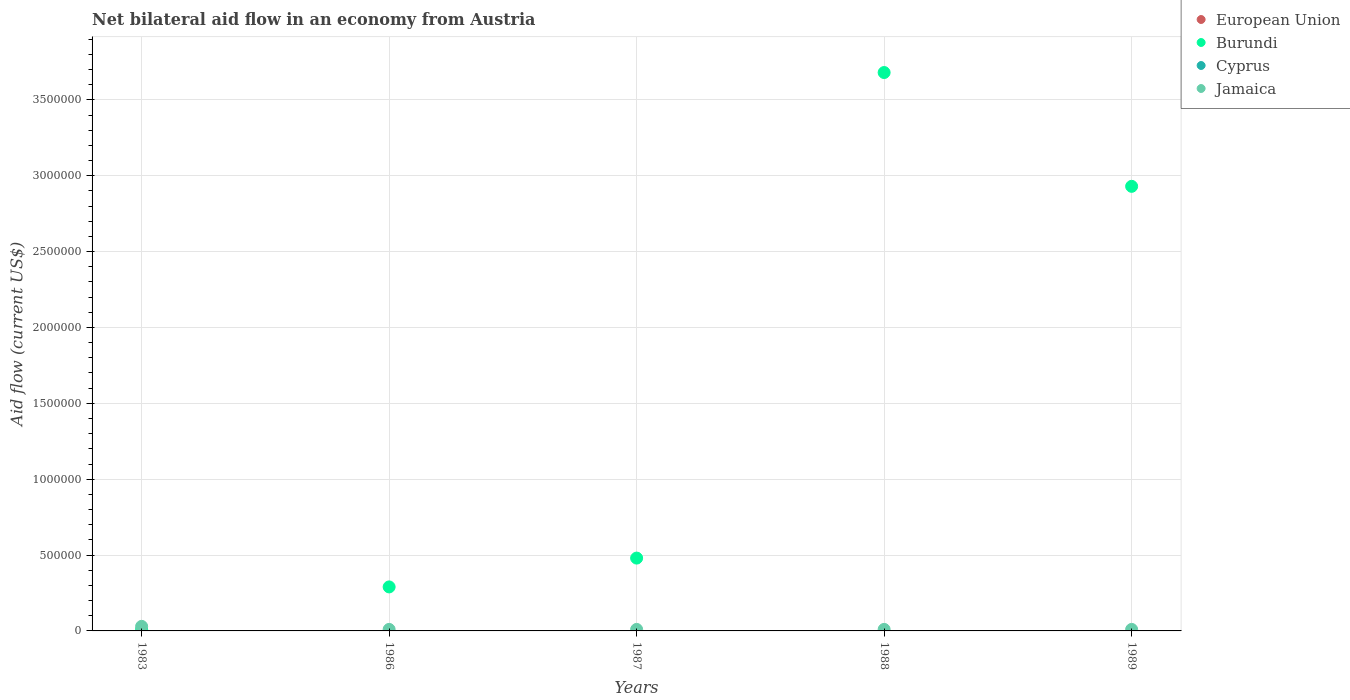What is the net bilateral aid flow in Burundi in 1986?
Ensure brevity in your answer.  2.90e+05. In which year was the net bilateral aid flow in Jamaica maximum?
Your answer should be very brief. 1983. What is the difference between the net bilateral aid flow in Burundi in 1989 and the net bilateral aid flow in Cyprus in 1983?
Provide a short and direct response. 2.93e+06. What is the ratio of the net bilateral aid flow in Burundi in 1986 to that in 1989?
Your answer should be compact. 0.1. Is the net bilateral aid flow in Burundi in 1986 less than that in 1989?
Offer a terse response. Yes. What is the difference between the highest and the second highest net bilateral aid flow in Burundi?
Give a very brief answer. 7.50e+05. Is it the case that in every year, the sum of the net bilateral aid flow in Jamaica and net bilateral aid flow in Burundi  is greater than the sum of net bilateral aid flow in Cyprus and net bilateral aid flow in European Union?
Give a very brief answer. Yes. Is it the case that in every year, the sum of the net bilateral aid flow in Cyprus and net bilateral aid flow in Burundi  is greater than the net bilateral aid flow in Jamaica?
Give a very brief answer. No. Is the net bilateral aid flow in Cyprus strictly greater than the net bilateral aid flow in Burundi over the years?
Make the answer very short. No. Is the net bilateral aid flow in Cyprus strictly less than the net bilateral aid flow in Jamaica over the years?
Give a very brief answer. Yes. How many dotlines are there?
Provide a short and direct response. 2. Are the values on the major ticks of Y-axis written in scientific E-notation?
Keep it short and to the point. No. Does the graph contain any zero values?
Provide a succinct answer. Yes. Does the graph contain grids?
Keep it short and to the point. Yes. How many legend labels are there?
Your answer should be compact. 4. What is the title of the graph?
Give a very brief answer. Net bilateral aid flow in an economy from Austria. What is the Aid flow (current US$) of Burundi in 1983?
Offer a terse response. 10000. What is the Aid flow (current US$) in Cyprus in 1983?
Provide a succinct answer. 0. What is the Aid flow (current US$) of Jamaica in 1983?
Your response must be concise. 3.00e+04. What is the Aid flow (current US$) of European Union in 1986?
Give a very brief answer. 0. What is the Aid flow (current US$) in Burundi in 1986?
Ensure brevity in your answer.  2.90e+05. What is the Aid flow (current US$) of Cyprus in 1986?
Your answer should be compact. 0. What is the Aid flow (current US$) of Burundi in 1988?
Make the answer very short. 3.68e+06. What is the Aid flow (current US$) of Cyprus in 1988?
Make the answer very short. 0. What is the Aid flow (current US$) of Jamaica in 1988?
Your answer should be compact. 10000. What is the Aid flow (current US$) in European Union in 1989?
Your answer should be very brief. 0. What is the Aid flow (current US$) in Burundi in 1989?
Your answer should be very brief. 2.93e+06. What is the Aid flow (current US$) in Cyprus in 1989?
Make the answer very short. 0. Across all years, what is the maximum Aid flow (current US$) in Burundi?
Give a very brief answer. 3.68e+06. Across all years, what is the minimum Aid flow (current US$) in Burundi?
Make the answer very short. 10000. Across all years, what is the minimum Aid flow (current US$) of Jamaica?
Provide a short and direct response. 10000. What is the total Aid flow (current US$) of European Union in the graph?
Your answer should be compact. 0. What is the total Aid flow (current US$) in Burundi in the graph?
Offer a very short reply. 7.39e+06. What is the total Aid flow (current US$) in Cyprus in the graph?
Offer a terse response. 0. What is the difference between the Aid flow (current US$) in Burundi in 1983 and that in 1986?
Make the answer very short. -2.80e+05. What is the difference between the Aid flow (current US$) of Jamaica in 1983 and that in 1986?
Ensure brevity in your answer.  2.00e+04. What is the difference between the Aid flow (current US$) in Burundi in 1983 and that in 1987?
Your answer should be compact. -4.70e+05. What is the difference between the Aid flow (current US$) of Burundi in 1983 and that in 1988?
Provide a short and direct response. -3.67e+06. What is the difference between the Aid flow (current US$) in Jamaica in 1983 and that in 1988?
Offer a very short reply. 2.00e+04. What is the difference between the Aid flow (current US$) of Burundi in 1983 and that in 1989?
Provide a succinct answer. -2.92e+06. What is the difference between the Aid flow (current US$) of Burundi in 1986 and that in 1987?
Your answer should be very brief. -1.90e+05. What is the difference between the Aid flow (current US$) in Jamaica in 1986 and that in 1987?
Make the answer very short. 0. What is the difference between the Aid flow (current US$) in Burundi in 1986 and that in 1988?
Your response must be concise. -3.39e+06. What is the difference between the Aid flow (current US$) of Burundi in 1986 and that in 1989?
Your answer should be very brief. -2.64e+06. What is the difference between the Aid flow (current US$) of Burundi in 1987 and that in 1988?
Keep it short and to the point. -3.20e+06. What is the difference between the Aid flow (current US$) in Jamaica in 1987 and that in 1988?
Make the answer very short. 0. What is the difference between the Aid flow (current US$) in Burundi in 1987 and that in 1989?
Ensure brevity in your answer.  -2.45e+06. What is the difference between the Aid flow (current US$) of Burundi in 1988 and that in 1989?
Your answer should be compact. 7.50e+05. What is the difference between the Aid flow (current US$) of Jamaica in 1988 and that in 1989?
Give a very brief answer. 0. What is the difference between the Aid flow (current US$) of Burundi in 1983 and the Aid flow (current US$) of Jamaica in 1987?
Keep it short and to the point. 0. What is the difference between the Aid flow (current US$) of Burundi in 1983 and the Aid flow (current US$) of Jamaica in 1988?
Offer a very short reply. 0. What is the difference between the Aid flow (current US$) in Burundi in 1986 and the Aid flow (current US$) in Jamaica in 1987?
Your response must be concise. 2.80e+05. What is the difference between the Aid flow (current US$) of Burundi in 1988 and the Aid flow (current US$) of Jamaica in 1989?
Your answer should be very brief. 3.67e+06. What is the average Aid flow (current US$) in European Union per year?
Your answer should be very brief. 0. What is the average Aid flow (current US$) in Burundi per year?
Provide a succinct answer. 1.48e+06. What is the average Aid flow (current US$) in Cyprus per year?
Your answer should be compact. 0. What is the average Aid flow (current US$) in Jamaica per year?
Your answer should be compact. 1.40e+04. In the year 1983, what is the difference between the Aid flow (current US$) in Burundi and Aid flow (current US$) in Jamaica?
Your response must be concise. -2.00e+04. In the year 1986, what is the difference between the Aid flow (current US$) of Burundi and Aid flow (current US$) of Jamaica?
Your answer should be compact. 2.80e+05. In the year 1988, what is the difference between the Aid flow (current US$) of Burundi and Aid flow (current US$) of Jamaica?
Your answer should be compact. 3.67e+06. In the year 1989, what is the difference between the Aid flow (current US$) in Burundi and Aid flow (current US$) in Jamaica?
Give a very brief answer. 2.92e+06. What is the ratio of the Aid flow (current US$) of Burundi in 1983 to that in 1986?
Ensure brevity in your answer.  0.03. What is the ratio of the Aid flow (current US$) in Jamaica in 1983 to that in 1986?
Provide a succinct answer. 3. What is the ratio of the Aid flow (current US$) in Burundi in 1983 to that in 1987?
Ensure brevity in your answer.  0.02. What is the ratio of the Aid flow (current US$) of Jamaica in 1983 to that in 1987?
Provide a short and direct response. 3. What is the ratio of the Aid flow (current US$) of Burundi in 1983 to that in 1988?
Your answer should be very brief. 0. What is the ratio of the Aid flow (current US$) of Jamaica in 1983 to that in 1988?
Make the answer very short. 3. What is the ratio of the Aid flow (current US$) in Burundi in 1983 to that in 1989?
Make the answer very short. 0. What is the ratio of the Aid flow (current US$) of Burundi in 1986 to that in 1987?
Provide a short and direct response. 0.6. What is the ratio of the Aid flow (current US$) in Burundi in 1986 to that in 1988?
Provide a short and direct response. 0.08. What is the ratio of the Aid flow (current US$) of Burundi in 1986 to that in 1989?
Give a very brief answer. 0.1. What is the ratio of the Aid flow (current US$) in Jamaica in 1986 to that in 1989?
Your answer should be very brief. 1. What is the ratio of the Aid flow (current US$) in Burundi in 1987 to that in 1988?
Offer a terse response. 0.13. What is the ratio of the Aid flow (current US$) in Burundi in 1987 to that in 1989?
Give a very brief answer. 0.16. What is the ratio of the Aid flow (current US$) in Jamaica in 1987 to that in 1989?
Your answer should be compact. 1. What is the ratio of the Aid flow (current US$) of Burundi in 1988 to that in 1989?
Provide a succinct answer. 1.26. What is the difference between the highest and the second highest Aid flow (current US$) of Burundi?
Ensure brevity in your answer.  7.50e+05. What is the difference between the highest and the lowest Aid flow (current US$) in Burundi?
Your response must be concise. 3.67e+06. 